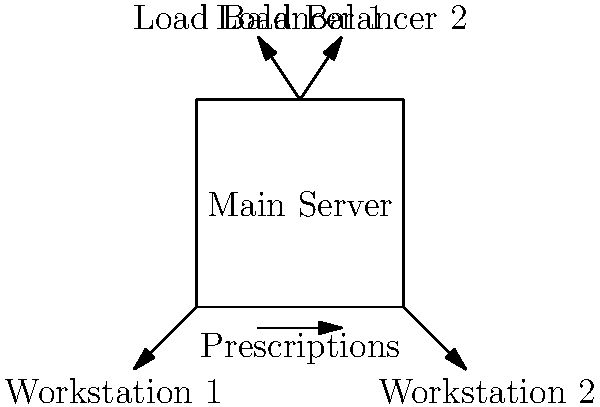In a busy pharmacy network during peak hours, which load balancing method would be most effective to distribute incoming prescription requests across multiple servers, ensuring efficient processing and minimal downtime? To determine the most effective load balancing method for a busy pharmacy network during peak hours, we need to consider several factors:

1. Nature of pharmacy workload:
   - Prescription processing involves database queries and updates
   - Requests may vary in complexity and processing time

2. Key requirements:
   - High availability
   - Fast response times
   - Even distribution of workload

3. Load balancing methods:
   a) Round Robin: Distributes requests sequentially
   b) Least Connections: Sends requests to server with fewest active connections
   c) Weighted Round Robin: Assigns weights to servers based on capacity
   d) IP Hash: Consistently routes requests from the same IP to the same server

4. Analysis for pharmacy scenario:
   - Least Connections method is most suitable because:
     i) It adapts to varying request complexities
     ii) Ensures even distribution of workload
     iii) Prevents overloading of any single server
     iv) Maintains optimal response times during peak hours

5. Implementation:
   - Configure load balancers to monitor active connections on each server
   - Direct new requests to the server with the lowest number of active connections
   - This approach balances the workload dynamically based on current server load

By using the Least Connections method, the pharmacy network can efficiently handle peak hour traffic, ensuring fast prescription processing and minimal downtime.
Answer: Least Connections method 